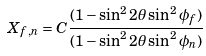Convert formula to latex. <formula><loc_0><loc_0><loc_500><loc_500>X _ { f , n } = C \frac { ( 1 - \sin ^ { 2 } 2 { \theta } \sin ^ { 2 } { \phi } _ { f } ) } { ( 1 - \sin ^ { 2 } 2 { \theta } \sin ^ { 2 } { \phi } _ { n } ) }</formula> 